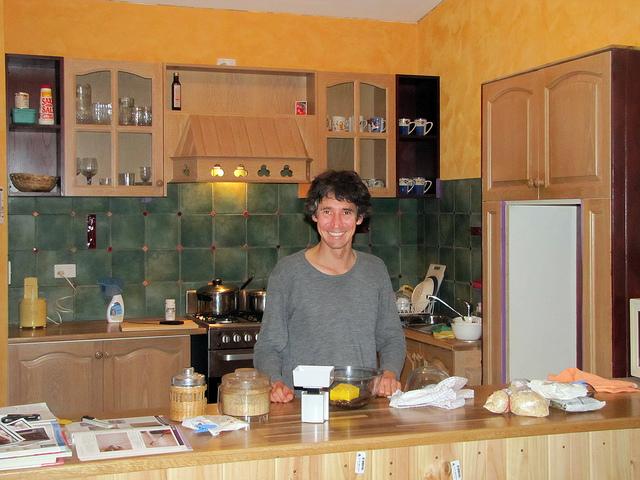How many glasses are on the table?
Be succinct. 0. What color is the backsplash?
Short answer required. Green. What color is the tiles?
Keep it brief. Green. Is it a man or a woman standing in the kitchen?
Be succinct. Man. Is this a bakery?
Give a very brief answer. No. 